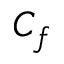<formula> <loc_0><loc_0><loc_500><loc_500>C _ { f }</formula> 